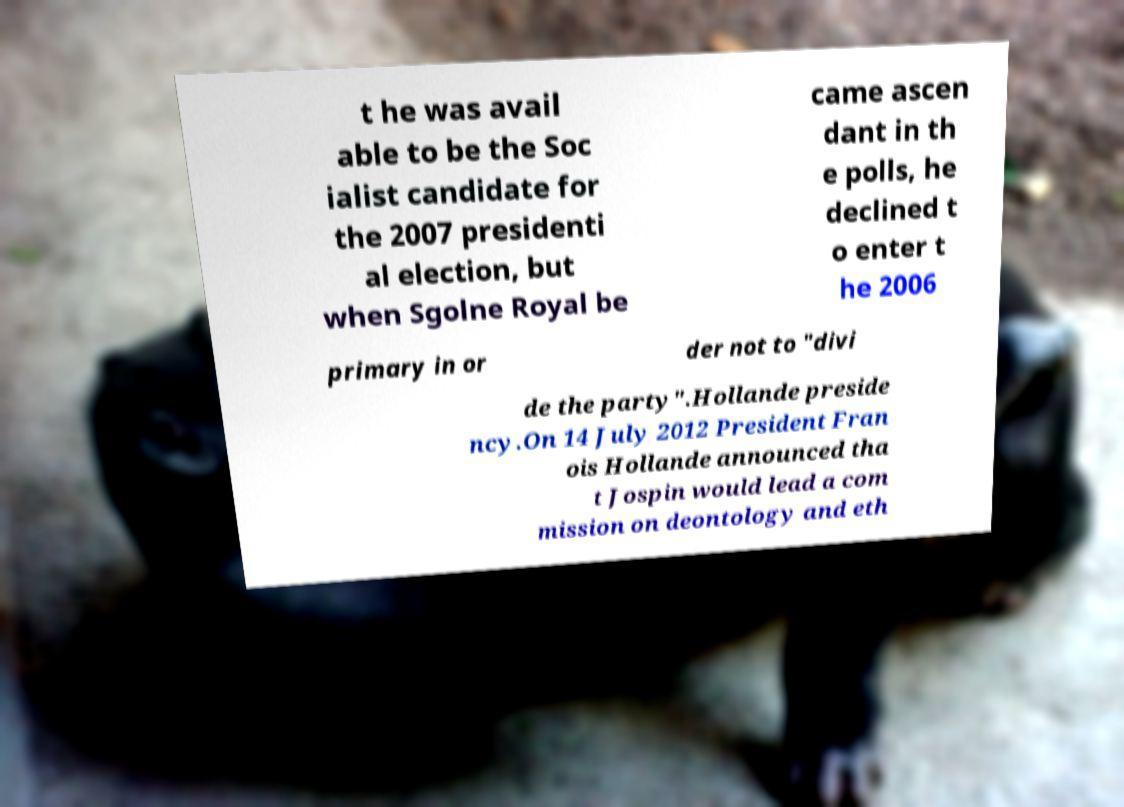There's text embedded in this image that I need extracted. Can you transcribe it verbatim? t he was avail able to be the Soc ialist candidate for the 2007 presidenti al election, but when Sgolne Royal be came ascen dant in th e polls, he declined t o enter t he 2006 primary in or der not to "divi de the party".Hollande preside ncy.On 14 July 2012 President Fran ois Hollande announced tha t Jospin would lead a com mission on deontology and eth 